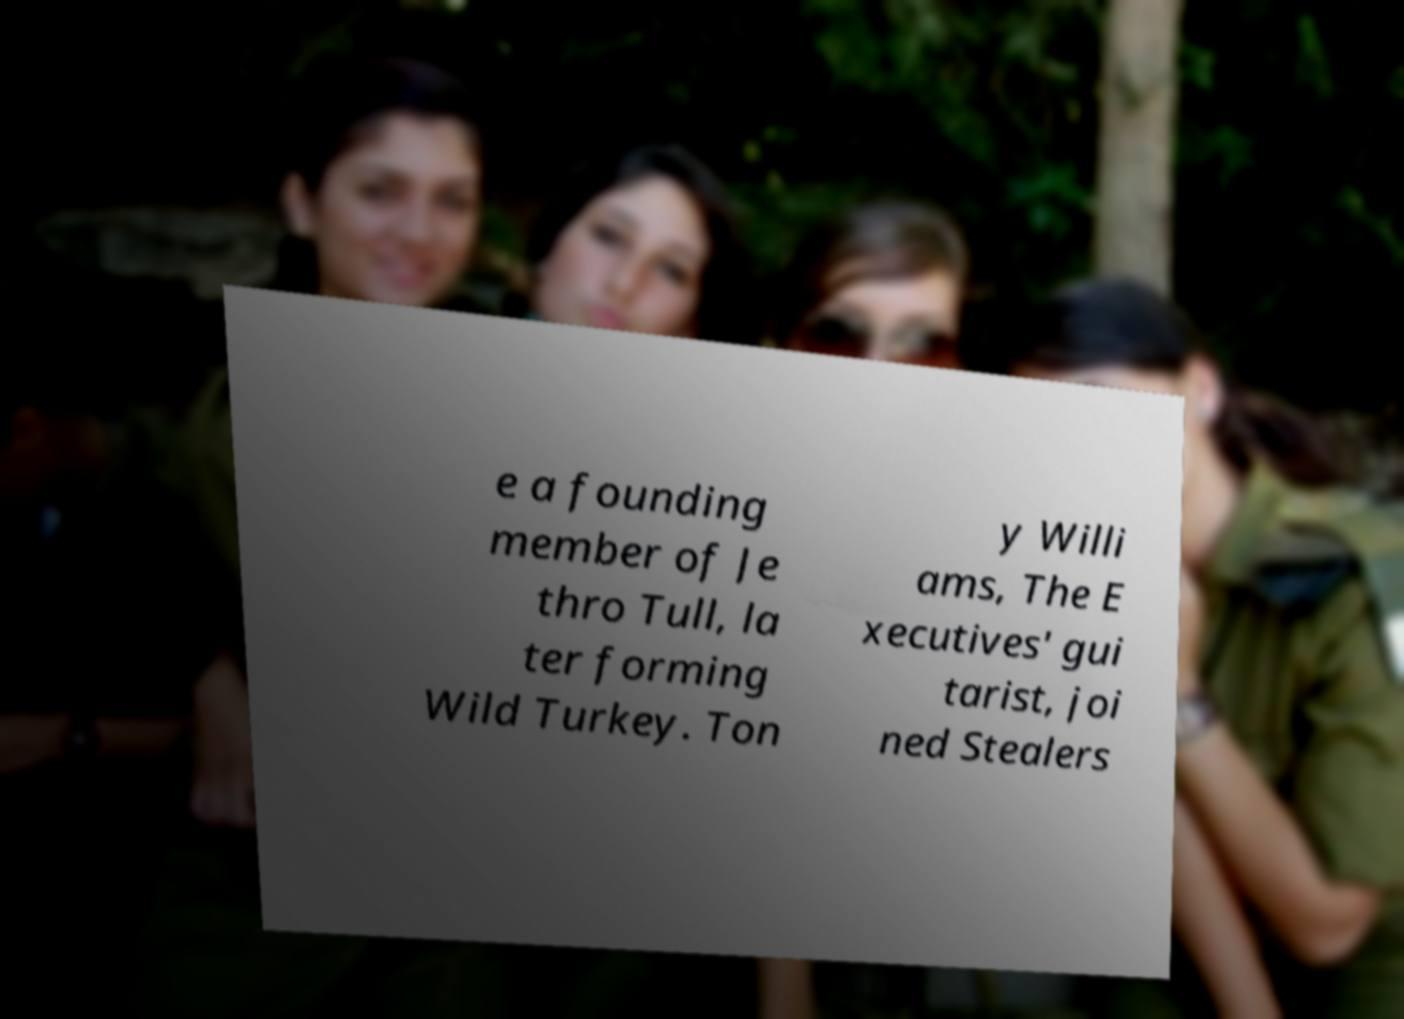What messages or text are displayed in this image? I need them in a readable, typed format. e a founding member of Je thro Tull, la ter forming Wild Turkey. Ton y Willi ams, The E xecutives' gui tarist, joi ned Stealers 